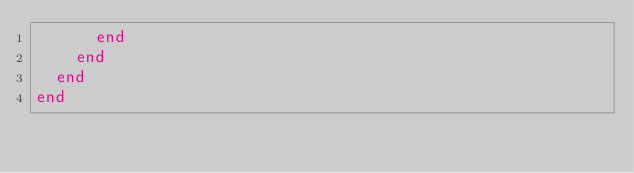Convert code to text. <code><loc_0><loc_0><loc_500><loc_500><_Ruby_>      end
    end
  end
end
</code> 